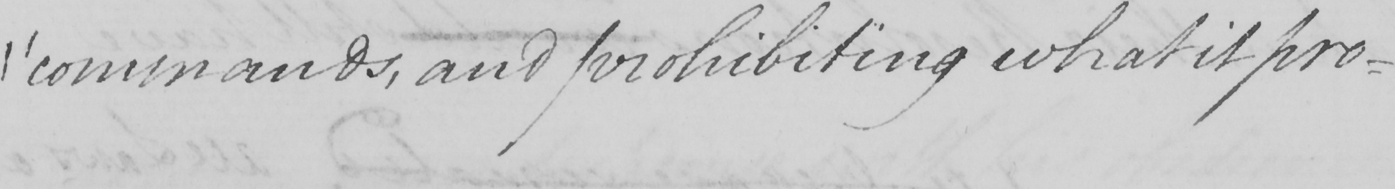Can you read and transcribe this handwriting? " commands , and prohibiting what it pro- 